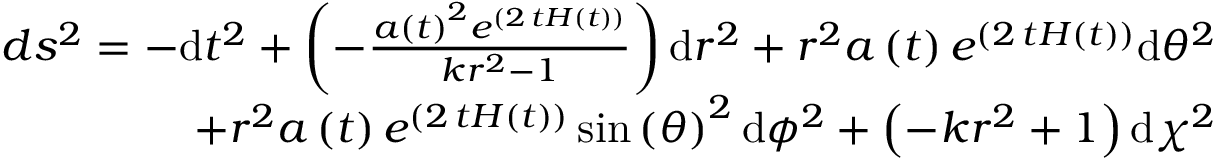<formula> <loc_0><loc_0><loc_500><loc_500>\begin{array} { r } { d s ^ { 2 } = - d t ^ { 2 } + \left ( - \frac { a \left ( t \right ) ^ { 2 } e ^ { \left ( 2 \, t H \left ( t \right ) \right ) } } { k r ^ { 2 } - 1 } \right ) d r ^ { 2 } + r ^ { 2 } a \left ( t \right ) e ^ { \left ( 2 \, t H \left ( t \right ) \right ) } d { \theta } ^ { 2 } } \\ { + r ^ { 2 } a \left ( t \right ) e ^ { \left ( 2 \, t H \left ( t \right ) \right ) } \sin \left ( { \theta } \right ) ^ { 2 } d { \phi } ^ { 2 } + \left ( - k r ^ { 2 } + 1 \right ) d { \chi } ^ { 2 } } \end{array}</formula> 